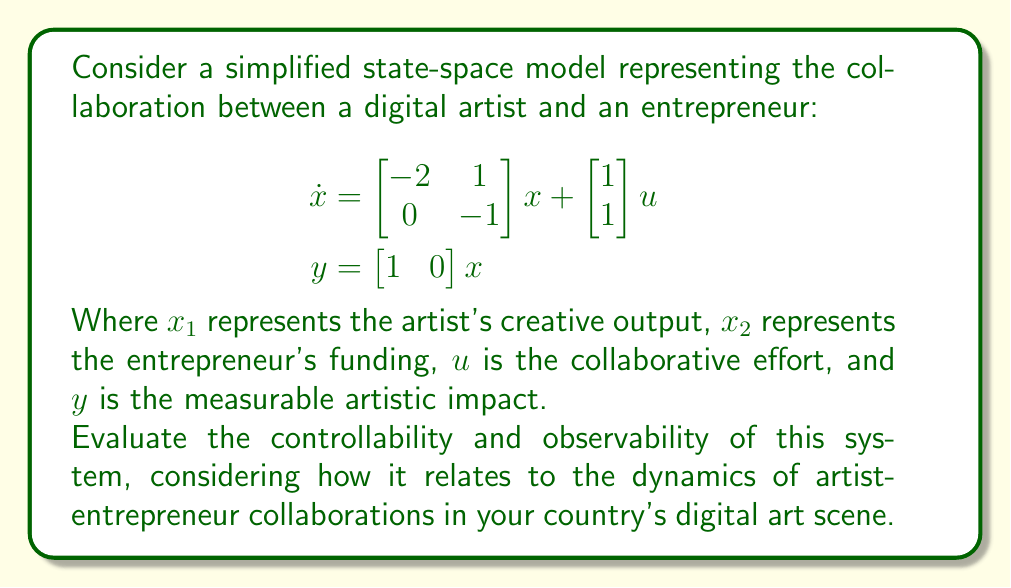Solve this math problem. To evaluate the controllability and observability of the system, we need to check the ranks of the controllability and observability matrices.

1. Controllability:
The controllability matrix is given by $C = [B \quad AB]$, where A and B are the system and input matrices respectively.

$$\begin{aligned}
B &= \begin{bmatrix} 1 \\ 1 \end{bmatrix} \\
AB &= \begin{bmatrix} -2 & 1 \\ 0 & -1 \end{bmatrix} \begin{bmatrix} 1 \\ 1 \end{bmatrix} = \begin{bmatrix} -1 \\ -1 \end{bmatrix} \\
C &= \begin{bmatrix} 1 & -1 \\ 1 & -1 \end{bmatrix}
\end{aligned}$$

The rank of C is 1, which is less than the system order (2). Therefore, the system is not completely controllable.

2. Observability:
The observability matrix is given by $O = \begin{bmatrix} C \\ CA \end{bmatrix}$, where C is the output matrix.

$$\begin{aligned}
C &= \begin{bmatrix} 1 & 0 \end{bmatrix} \\
CA &= \begin{bmatrix} 1 & 0 \end{bmatrix} \begin{bmatrix} -2 & 1 \\ 0 & -1 \end{bmatrix} = \begin{bmatrix} -2 & 1 \end{bmatrix} \\
O &= \begin{bmatrix} 1 & 0 \\ -2 & 1 \end{bmatrix}
\end{aligned}$$

The rank of O is 2, which is equal to the system order. Therefore, the system is completely observable.

Interpretation:
In the context of artist-entrepreneur collaborations, this system suggests that while we can fully observe the state of the collaboration (both creative output and funding), we may not have complete control over both aspects simultaneously. This could reflect the complex nature of artistic creation and financial support in the digital art scene, where funding alone may not guarantee specific creative outcomes.
Answer: The system is not completely controllable but is completely observable. 